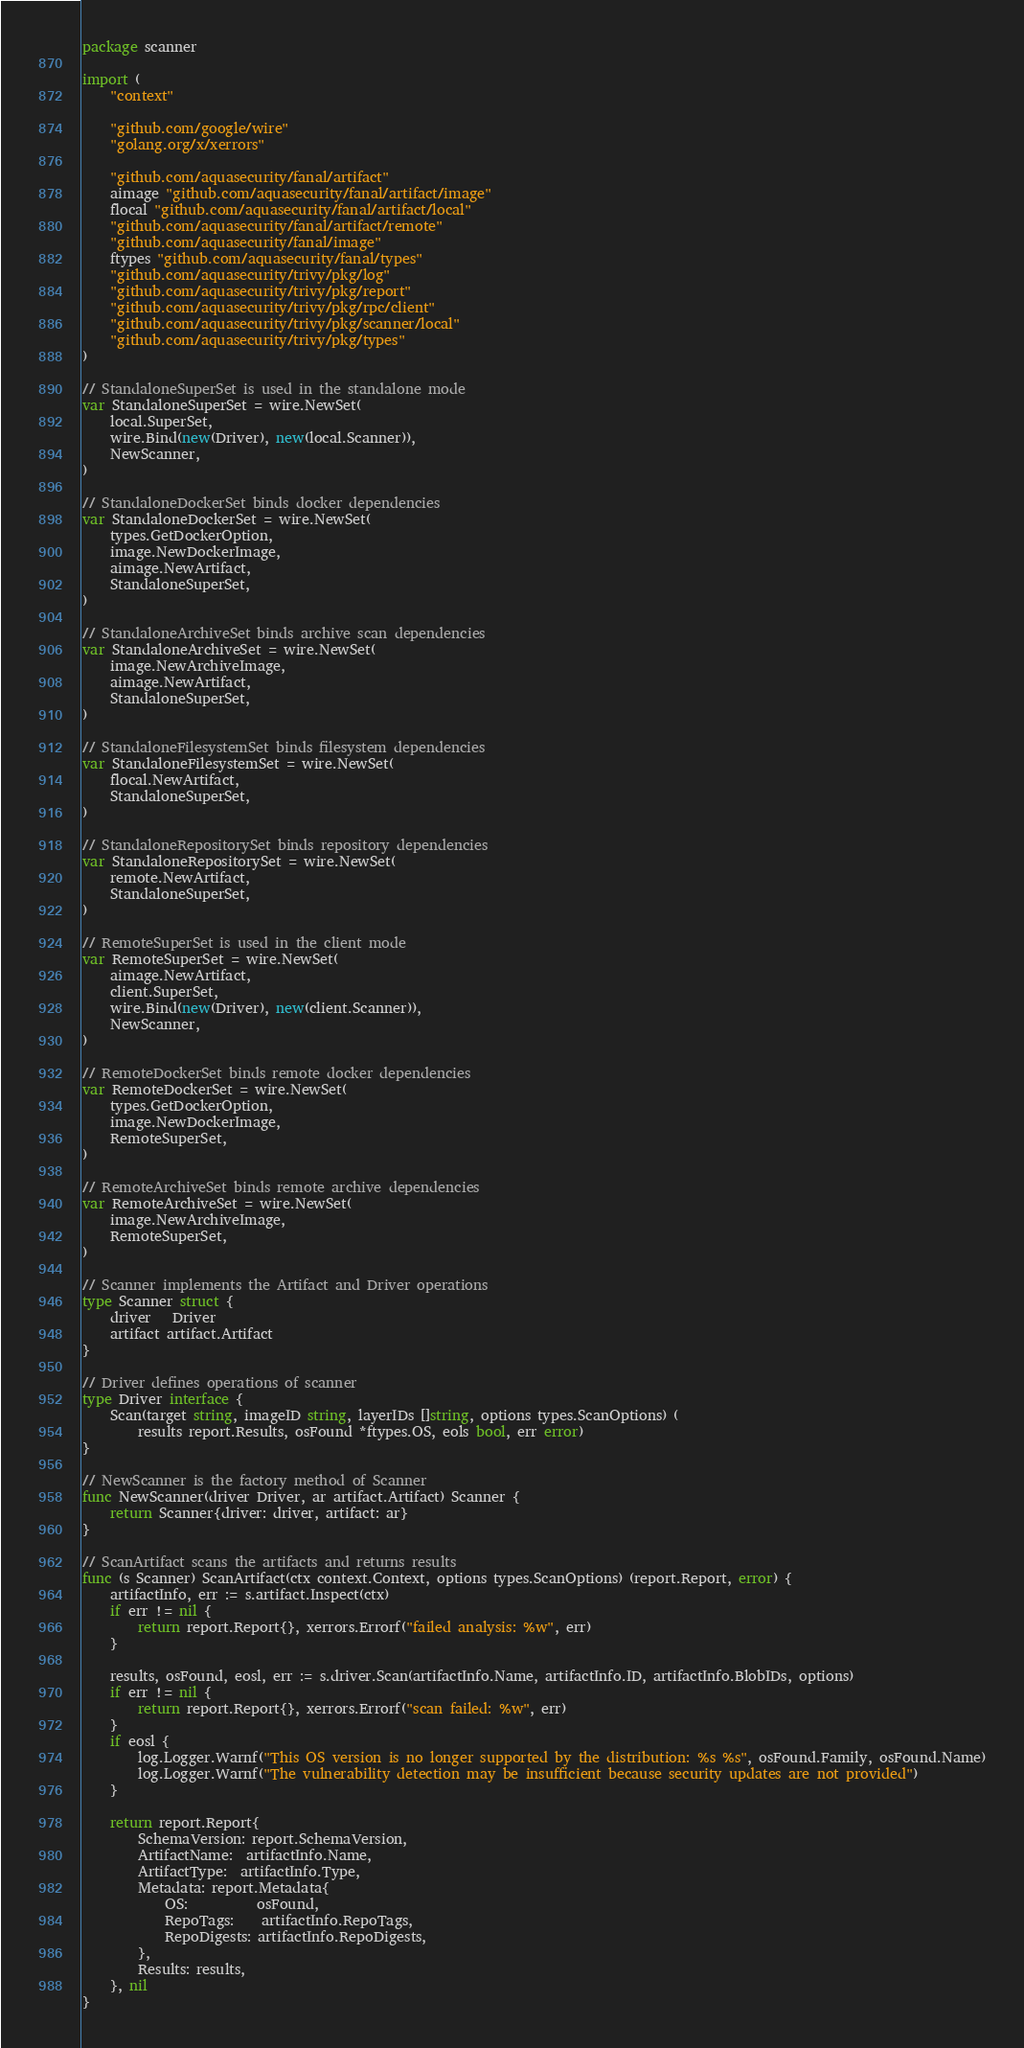Convert code to text. <code><loc_0><loc_0><loc_500><loc_500><_Go_>package scanner

import (
	"context"

	"github.com/google/wire"
	"golang.org/x/xerrors"

	"github.com/aquasecurity/fanal/artifact"
	aimage "github.com/aquasecurity/fanal/artifact/image"
	flocal "github.com/aquasecurity/fanal/artifact/local"
	"github.com/aquasecurity/fanal/artifact/remote"
	"github.com/aquasecurity/fanal/image"
	ftypes "github.com/aquasecurity/fanal/types"
	"github.com/aquasecurity/trivy/pkg/log"
	"github.com/aquasecurity/trivy/pkg/report"
	"github.com/aquasecurity/trivy/pkg/rpc/client"
	"github.com/aquasecurity/trivy/pkg/scanner/local"
	"github.com/aquasecurity/trivy/pkg/types"
)

// StandaloneSuperSet is used in the standalone mode
var StandaloneSuperSet = wire.NewSet(
	local.SuperSet,
	wire.Bind(new(Driver), new(local.Scanner)),
	NewScanner,
)

// StandaloneDockerSet binds docker dependencies
var StandaloneDockerSet = wire.NewSet(
	types.GetDockerOption,
	image.NewDockerImage,
	aimage.NewArtifact,
	StandaloneSuperSet,
)

// StandaloneArchiveSet binds archive scan dependencies
var StandaloneArchiveSet = wire.NewSet(
	image.NewArchiveImage,
	aimage.NewArtifact,
	StandaloneSuperSet,
)

// StandaloneFilesystemSet binds filesystem dependencies
var StandaloneFilesystemSet = wire.NewSet(
	flocal.NewArtifact,
	StandaloneSuperSet,
)

// StandaloneRepositorySet binds repository dependencies
var StandaloneRepositorySet = wire.NewSet(
	remote.NewArtifact,
	StandaloneSuperSet,
)

// RemoteSuperSet is used in the client mode
var RemoteSuperSet = wire.NewSet(
	aimage.NewArtifact,
	client.SuperSet,
	wire.Bind(new(Driver), new(client.Scanner)),
	NewScanner,
)

// RemoteDockerSet binds remote docker dependencies
var RemoteDockerSet = wire.NewSet(
	types.GetDockerOption,
	image.NewDockerImage,
	RemoteSuperSet,
)

// RemoteArchiveSet binds remote archive dependencies
var RemoteArchiveSet = wire.NewSet(
	image.NewArchiveImage,
	RemoteSuperSet,
)

// Scanner implements the Artifact and Driver operations
type Scanner struct {
	driver   Driver
	artifact artifact.Artifact
}

// Driver defines operations of scanner
type Driver interface {
	Scan(target string, imageID string, layerIDs []string, options types.ScanOptions) (
		results report.Results, osFound *ftypes.OS, eols bool, err error)
}

// NewScanner is the factory method of Scanner
func NewScanner(driver Driver, ar artifact.Artifact) Scanner {
	return Scanner{driver: driver, artifact: ar}
}

// ScanArtifact scans the artifacts and returns results
func (s Scanner) ScanArtifact(ctx context.Context, options types.ScanOptions) (report.Report, error) {
	artifactInfo, err := s.artifact.Inspect(ctx)
	if err != nil {
		return report.Report{}, xerrors.Errorf("failed analysis: %w", err)
	}

	results, osFound, eosl, err := s.driver.Scan(artifactInfo.Name, artifactInfo.ID, artifactInfo.BlobIDs, options)
	if err != nil {
		return report.Report{}, xerrors.Errorf("scan failed: %w", err)
	}
	if eosl {
		log.Logger.Warnf("This OS version is no longer supported by the distribution: %s %s", osFound.Family, osFound.Name)
		log.Logger.Warnf("The vulnerability detection may be insufficient because security updates are not provided")
	}

	return report.Report{
		SchemaVersion: report.SchemaVersion,
		ArtifactName:  artifactInfo.Name,
		ArtifactType:  artifactInfo.Type,
		Metadata: report.Metadata{
			OS:          osFound,
			RepoTags:    artifactInfo.RepoTags,
			RepoDigests: artifactInfo.RepoDigests,
		},
		Results: results,
	}, nil
}
</code> 